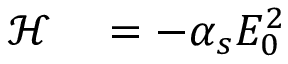<formula> <loc_0><loc_0><loc_500><loc_500>\begin{array} { r l } { \mathcal { H } } & = - \alpha _ { s } E _ { 0 } ^ { 2 } } \end{array}</formula> 